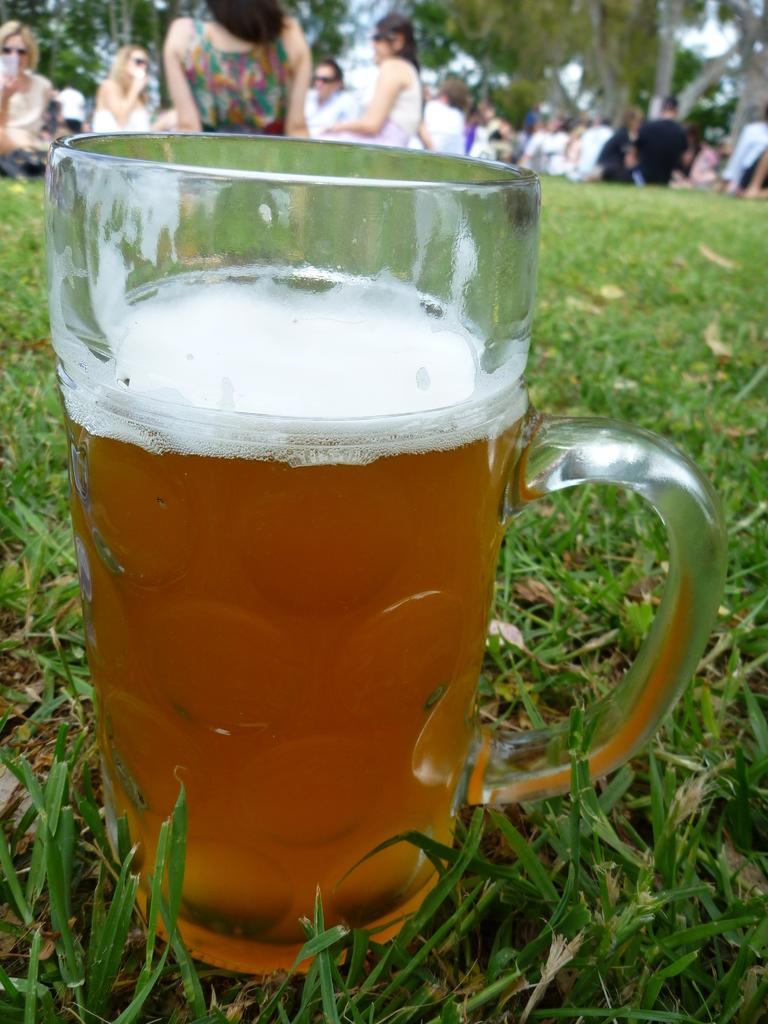What is the main object in the center of the image? There is a beer mug in the center of the image. Where is the beer mug located? The beer mug is on the grass. What can be seen in the background of the image? There are people and trees in the background of the image. What type of curtain is hanging from the beer mug in the image? There is no curtain present in the image; it features a beer mug on the grass with people and trees in the background. How does the glove help maintain balance for the beer mug in the image? There is no glove present in the image, and the beer mug does not require any assistance to maintain balance. 